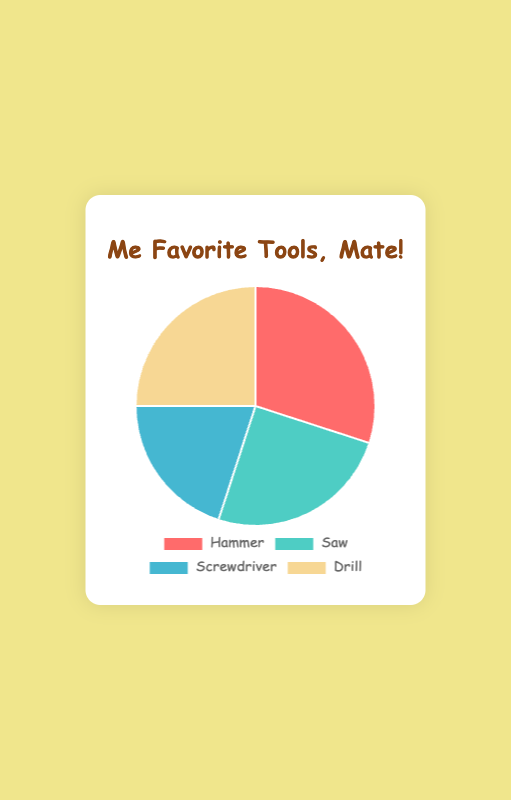Which tool is used the most frequently? The chart shows that the Hammer is used by 30% of the people, which is the highest percentage among all the tools.
Answer: Hammer Which two tools are used equally? By examining the percentages displayed on the pie chart, the Saw and Drill both register a usage percentage of 25%. Therefore, they are used equally.
Answer: Saw and Drill What is the combined percentage usage of the Hammer and Drill? The Hammer has a usage of 30%, and the Drill has a usage of 25%. Adding these two percentages together, you get 30% + 25% = 55%.
Answer: 55% Which tool is used the least frequently, and what is its percentage? The Screwdriver has the lowest usage, indicated by the smallest segment on the pie chart which shows a 20% usage.
Answer: Screwdriver, 20% How much more frequently is the Hammer used compared to the Screwdriver? The Hammer is used 30% of the time while the Screwdriver is used 20% of the time. To find the difference, subtract 20% from 30%, resulting in 30% - 20% = 10%.
Answer: 10% Does the combined usage of the Saw and Screwdriver exceed the usage of the Hammer? The Saw is used 25% and the Screwdriver is used 20%. Together, they account for 25% + 20% = 45%, which is less than the Hammer’s 30%.
Answer: No What is the average usage percentage of all tools? To calculate the average, sum the percentages of all tools: 30% + 25% + 20% + 25% = 100%. Then divide by the number of tools (4): 100% / 4 = 25%.
Answer: 25% Which segment on the pie chart has the yellow color, and what is its percentage? The pie chart uses different colors for each tool. The segment with a yellow color represents the Drill, which has a usage of 25%.
Answer: Drill, 25% 